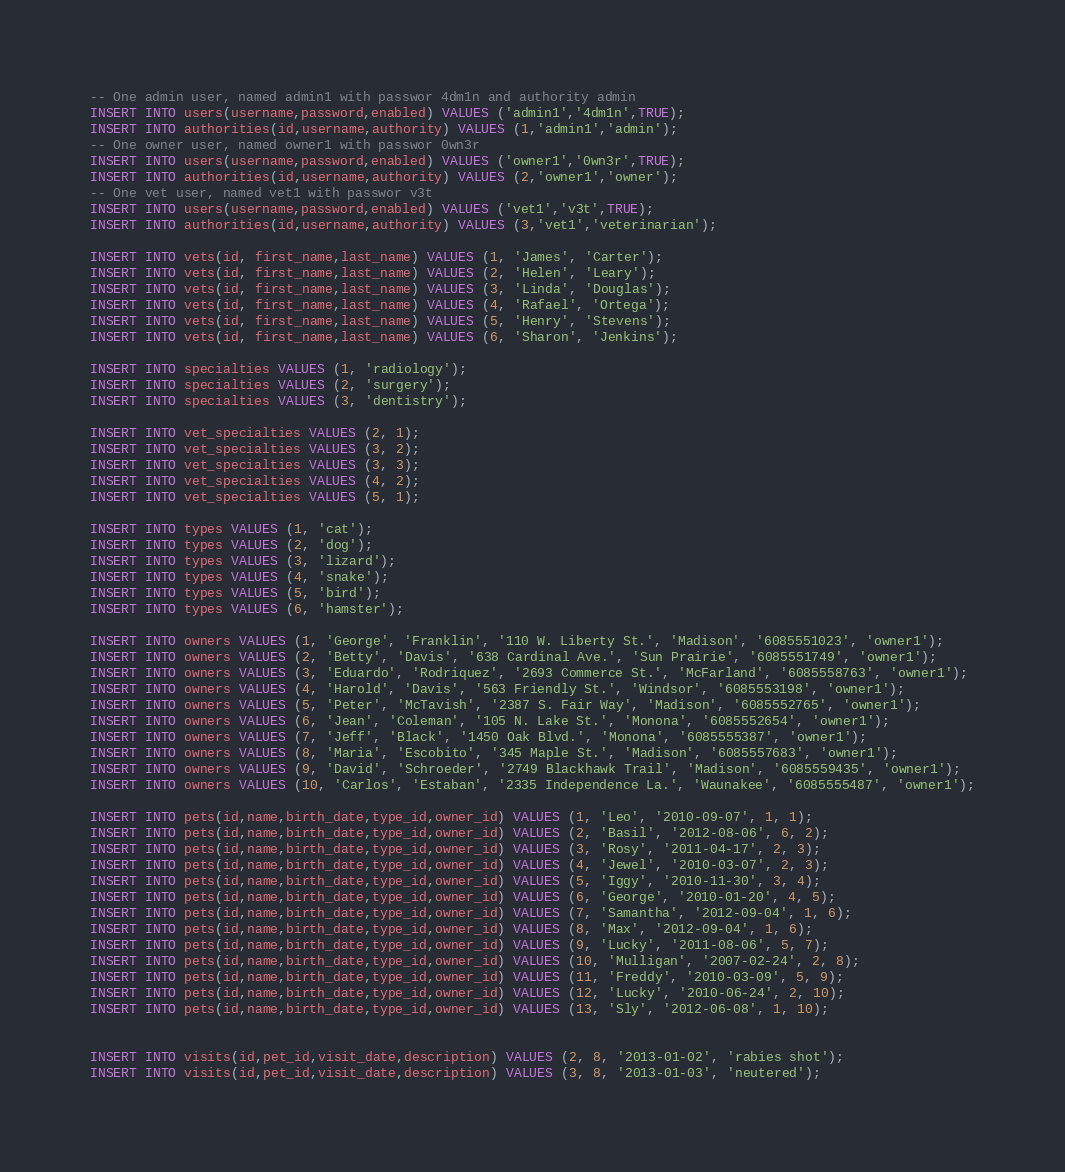Convert code to text. <code><loc_0><loc_0><loc_500><loc_500><_SQL_>-- One admin user, named admin1 with passwor 4dm1n and authority admin
INSERT INTO users(username,password,enabled) VALUES ('admin1','4dm1n',TRUE);
INSERT INTO authorities(id,username,authority) VALUES (1,'admin1','admin');
-- One owner user, named owner1 with passwor 0wn3r
INSERT INTO users(username,password,enabled) VALUES ('owner1','0wn3r',TRUE);
INSERT INTO authorities(id,username,authority) VALUES (2,'owner1','owner');
-- One vet user, named vet1 with passwor v3t
INSERT INTO users(username,password,enabled) VALUES ('vet1','v3t',TRUE);
INSERT INTO authorities(id,username,authority) VALUES (3,'vet1','veterinarian');

INSERT INTO vets(id, first_name,last_name) VALUES (1, 'James', 'Carter');
INSERT INTO vets(id, first_name,last_name) VALUES (2, 'Helen', 'Leary');
INSERT INTO vets(id, first_name,last_name) VALUES (3, 'Linda', 'Douglas');
INSERT INTO vets(id, first_name,last_name) VALUES (4, 'Rafael', 'Ortega');
INSERT INTO vets(id, first_name,last_name) VALUES (5, 'Henry', 'Stevens');
INSERT INTO vets(id, first_name,last_name) VALUES (6, 'Sharon', 'Jenkins');

INSERT INTO specialties VALUES (1, 'radiology');
INSERT INTO specialties VALUES (2, 'surgery');
INSERT INTO specialties VALUES (3, 'dentistry');

INSERT INTO vet_specialties VALUES (2, 1);
INSERT INTO vet_specialties VALUES (3, 2);
INSERT INTO vet_specialties VALUES (3, 3);
INSERT INTO vet_specialties VALUES (4, 2);
INSERT INTO vet_specialties VALUES (5, 1);

INSERT INTO types VALUES (1, 'cat');
INSERT INTO types VALUES (2, 'dog');
INSERT INTO types VALUES (3, 'lizard');
INSERT INTO types VALUES (4, 'snake');
INSERT INTO types VALUES (5, 'bird');
INSERT INTO types VALUES (6, 'hamster');

INSERT INTO owners VALUES (1, 'George', 'Franklin', '110 W. Liberty St.', 'Madison', '6085551023', 'owner1');
INSERT INTO owners VALUES (2, 'Betty', 'Davis', '638 Cardinal Ave.', 'Sun Prairie', '6085551749', 'owner1');
INSERT INTO owners VALUES (3, 'Eduardo', 'Rodriquez', '2693 Commerce St.', 'McFarland', '6085558763', 'owner1');
INSERT INTO owners VALUES (4, 'Harold', 'Davis', '563 Friendly St.', 'Windsor', '6085553198', 'owner1');
INSERT INTO owners VALUES (5, 'Peter', 'McTavish', '2387 S. Fair Way', 'Madison', '6085552765', 'owner1');
INSERT INTO owners VALUES (6, 'Jean', 'Coleman', '105 N. Lake St.', 'Monona', '6085552654', 'owner1');
INSERT INTO owners VALUES (7, 'Jeff', 'Black', '1450 Oak Blvd.', 'Monona', '6085555387', 'owner1');
INSERT INTO owners VALUES (8, 'Maria', 'Escobito', '345 Maple St.', 'Madison', '6085557683', 'owner1');
INSERT INTO owners VALUES (9, 'David', 'Schroeder', '2749 Blackhawk Trail', 'Madison', '6085559435', 'owner1');
INSERT INTO owners VALUES (10, 'Carlos', 'Estaban', '2335 Independence La.', 'Waunakee', '6085555487', 'owner1');

INSERT INTO pets(id,name,birth_date,type_id,owner_id) VALUES (1, 'Leo', '2010-09-07', 1, 1);
INSERT INTO pets(id,name,birth_date,type_id,owner_id) VALUES (2, 'Basil', '2012-08-06', 6, 2);
INSERT INTO pets(id,name,birth_date,type_id,owner_id) VALUES (3, 'Rosy', '2011-04-17', 2, 3);
INSERT INTO pets(id,name,birth_date,type_id,owner_id) VALUES (4, 'Jewel', '2010-03-07', 2, 3);
INSERT INTO pets(id,name,birth_date,type_id,owner_id) VALUES (5, 'Iggy', '2010-11-30', 3, 4);
INSERT INTO pets(id,name,birth_date,type_id,owner_id) VALUES (6, 'George', '2010-01-20', 4, 5);
INSERT INTO pets(id,name,birth_date,type_id,owner_id) VALUES (7, 'Samantha', '2012-09-04', 1, 6);
INSERT INTO pets(id,name,birth_date,type_id,owner_id) VALUES (8, 'Max', '2012-09-04', 1, 6);
INSERT INTO pets(id,name,birth_date,type_id,owner_id) VALUES (9, 'Lucky', '2011-08-06', 5, 7);
INSERT INTO pets(id,name,birth_date,type_id,owner_id) VALUES (10, 'Mulligan', '2007-02-24', 2, 8);
INSERT INTO pets(id,name,birth_date,type_id,owner_id) VALUES (11, 'Freddy', '2010-03-09', 5, 9);
INSERT INTO pets(id,name,birth_date,type_id,owner_id) VALUES (12, 'Lucky', '2010-06-24', 2, 10);
INSERT INTO pets(id,name,birth_date,type_id,owner_id) VALUES (13, 'Sly', '2012-06-08', 1, 10);


INSERT INTO visits(id,pet_id,visit_date,description) VALUES (2, 8, '2013-01-02', 'rabies shot');
INSERT INTO visits(id,pet_id,visit_date,description) VALUES (3, 8, '2013-01-03', 'neutered');</code> 